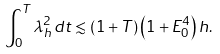Convert formula to latex. <formula><loc_0><loc_0><loc_500><loc_500>\int _ { 0 } ^ { T } \lambda _ { h } ^ { 2 } \, d t \lesssim \left ( 1 + T \right ) \left ( 1 + E _ { 0 } ^ { 4 } \right ) h .</formula> 